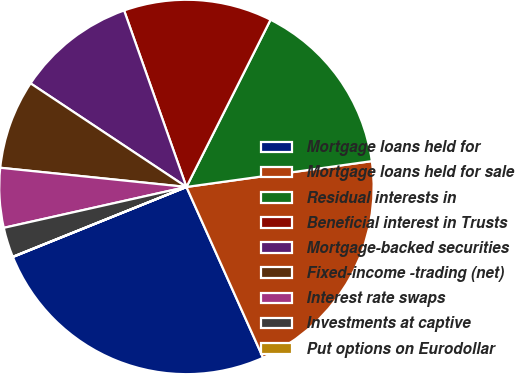Convert chart to OTSL. <chart><loc_0><loc_0><loc_500><loc_500><pie_chart><fcel>Mortgage loans held for<fcel>Mortgage loans held for sale<fcel>Residual interests in<fcel>Beneficial interest in Trusts<fcel>Mortgage-backed securities<fcel>Fixed-income -trading (net)<fcel>Interest rate swaps<fcel>Investments at captive<fcel>Put options on Eurodollar<nl><fcel>25.61%<fcel>20.49%<fcel>15.38%<fcel>12.82%<fcel>10.26%<fcel>7.7%<fcel>5.14%<fcel>2.58%<fcel>0.02%<nl></chart> 